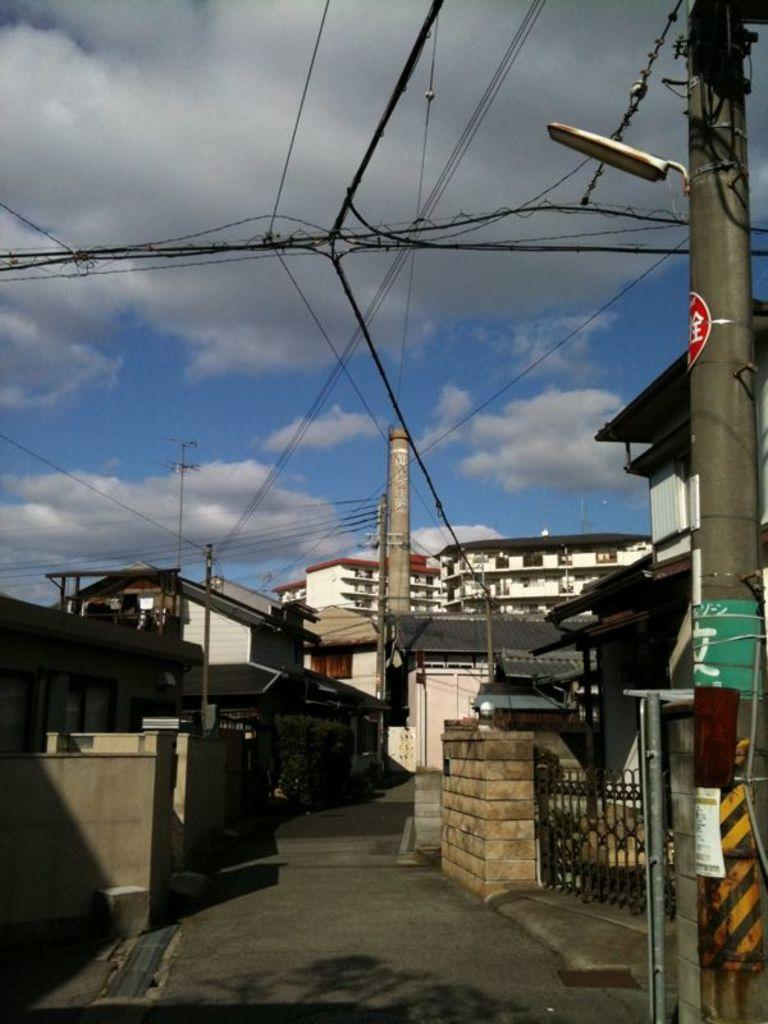What type of structures can be seen in the image? There are buildings in the image. What feature do the buildings have? The buildings have metal gates. What else can be seen in the image besides the buildings? There are electric poles with cables in the image. What function do the lamps on top of the electric poles serve? The lamps on top of the electric poles provide lighting. What is visible in the sky at the top of the image? There are clouds visible in the sky. What type of bag is the girl carrying in the image? There is no girl or bag present in the image. 